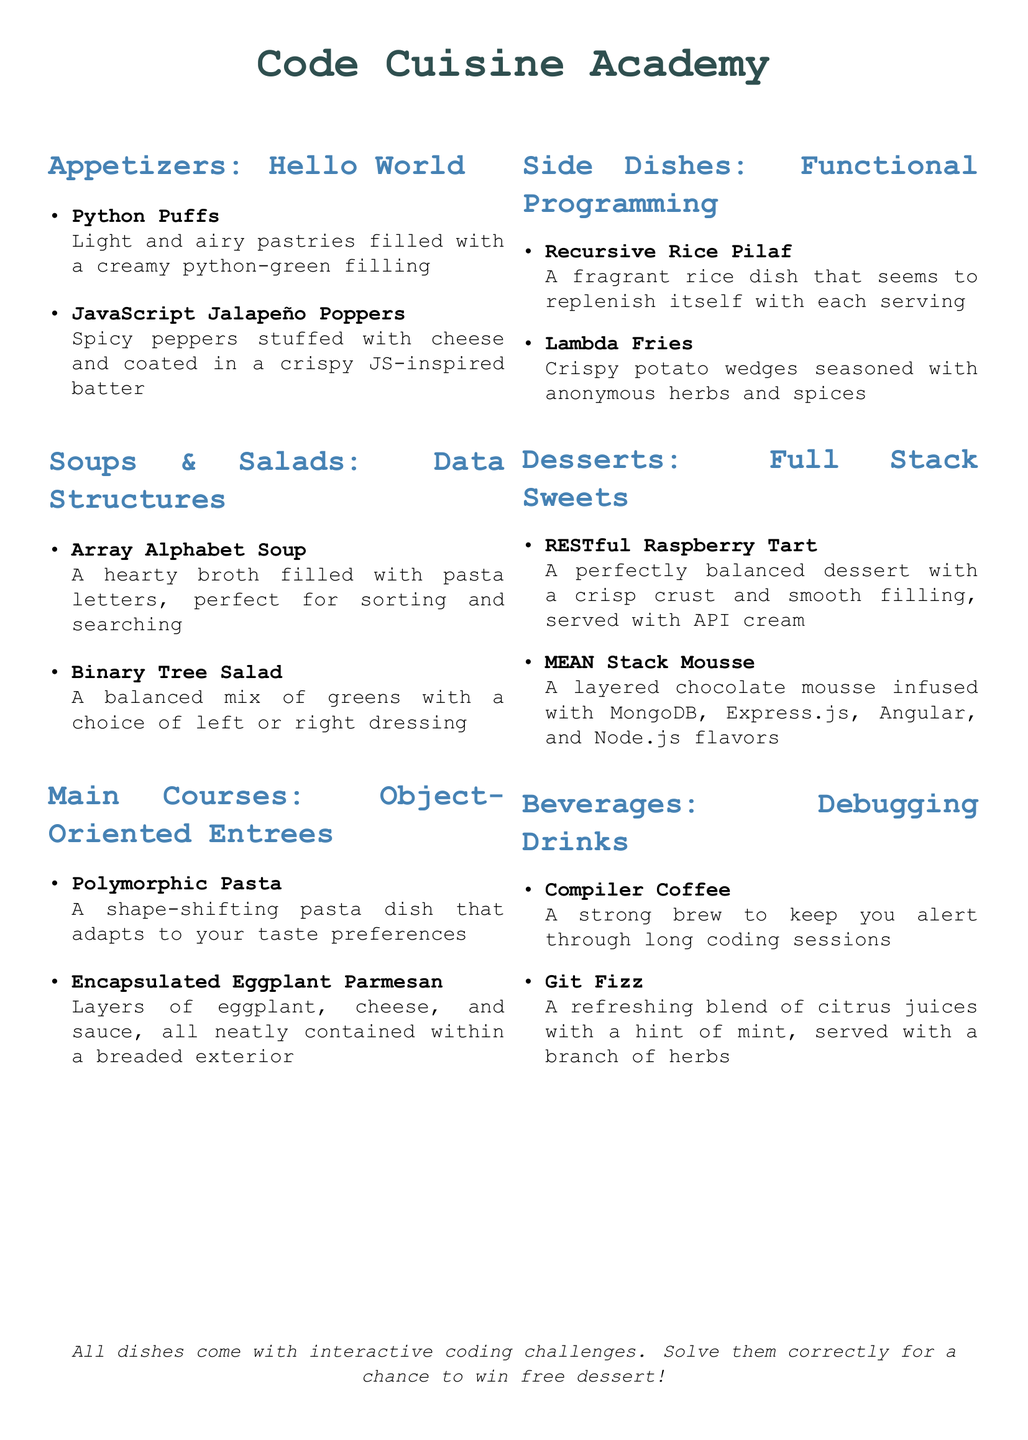What are the appetizers called? The appetizers are categorized under "Hello World" and listed in the document.
Answer: Hello World How many items are in the soups & salads section? The soups & salads section includes two items as listed in the document.
Answer: 2 What is the name of the dessert that includes a raspberry tart? The dessert with raspberry tart is specifically named in the document under the desserts section.
Answer: RESTful Raspberry Tart Which dish features a crispy exterior? The dish with a crispy exterior is detailed in the main courses section of the document.
Answer: Encapsulated Eggplant Parmesan What beverage is served with a hint of mint? A refreshing drink with mint is listed in the beverages section of the document.
Answer: Git Fizz How many main course options are there? The main courses section includes two distinct options as enumerated in the document.
Answer: 2 What type of dish is Recursive Rice Pilaf described as? The Recursive Rice Pilaf is specifically categorized within the side dishes section in the document.
Answer: Side dish What is the theme of the entire menu? The theme of the menu relates to a coding bootcamp and is reflected throughout the various sections.
Answer: Coding bootcamp 